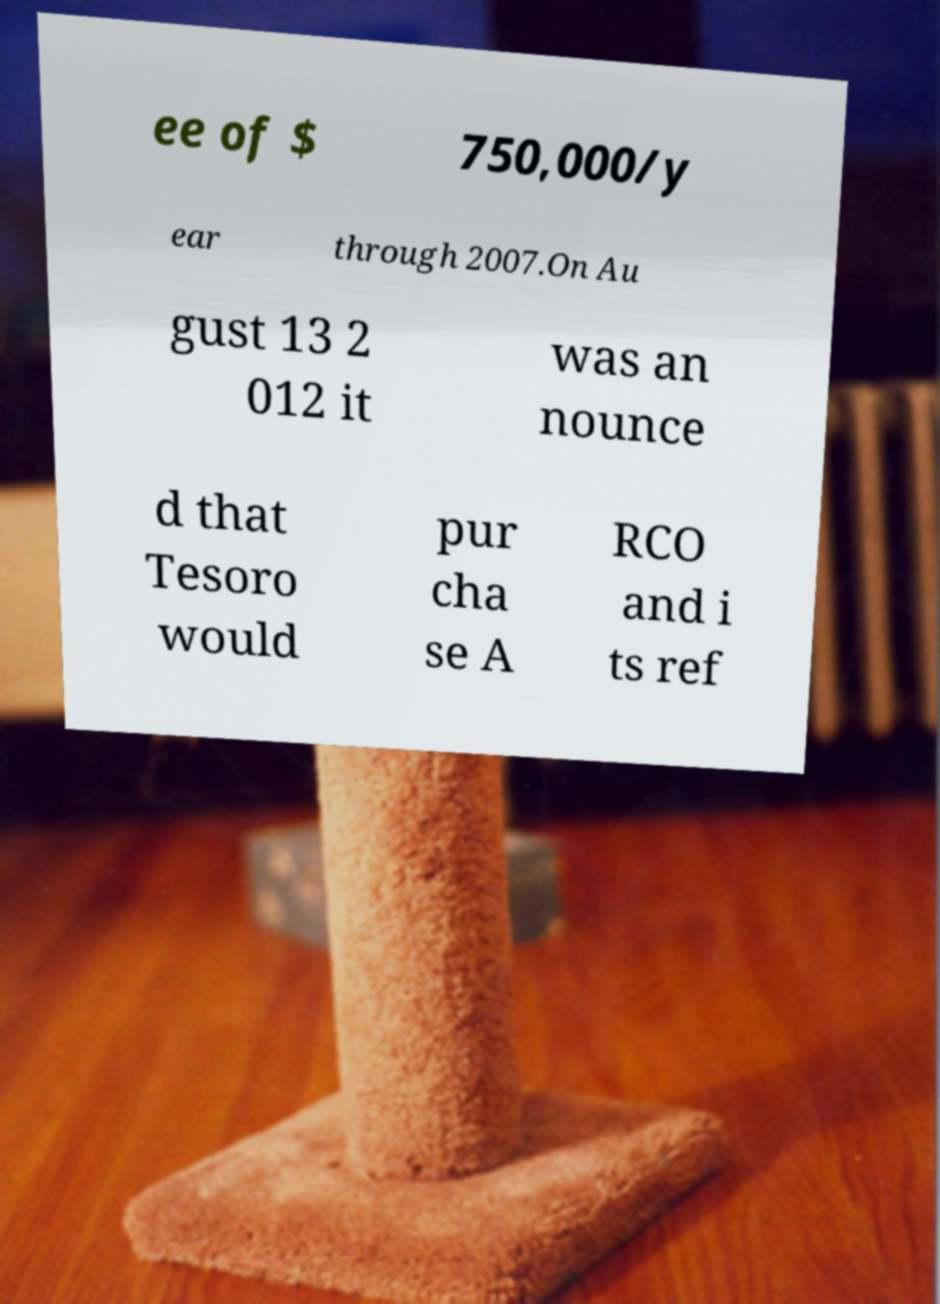What messages or text are displayed in this image? I need them in a readable, typed format. ee of $ 750,000/y ear through 2007.On Au gust 13 2 012 it was an nounce d that Tesoro would pur cha se A RCO and i ts ref 